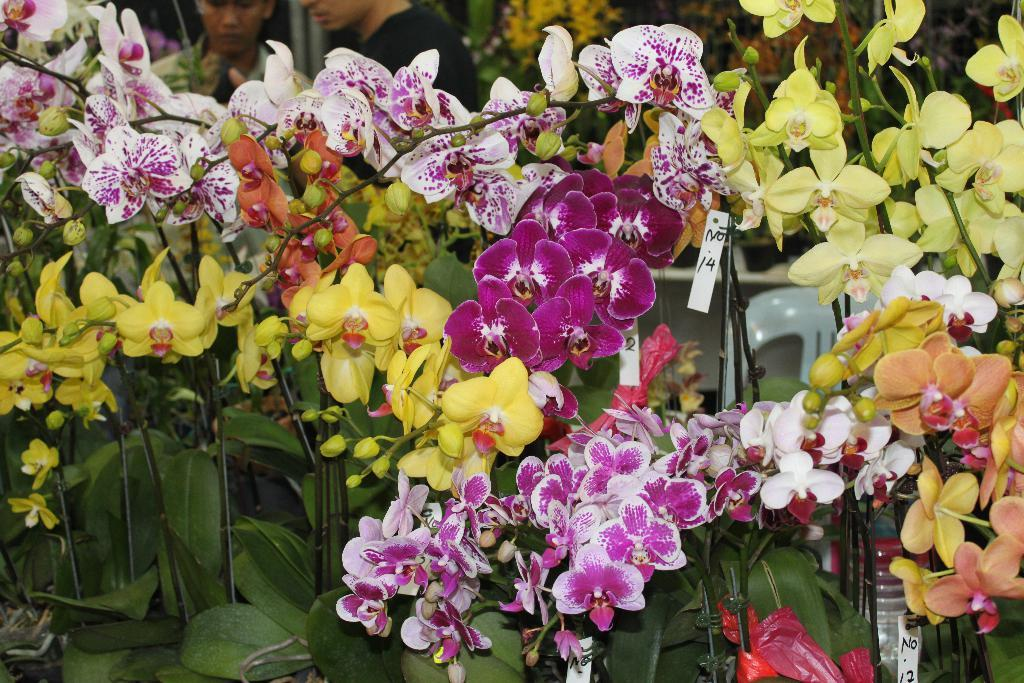What type of plants are visible in the image? There are plants with flowers in the image. What is located behind the plants? There is a chair and two persons behind the plants. What degree do the plants have in the image? The plants do not have a degree in the image; they are simply plants with flowers. 